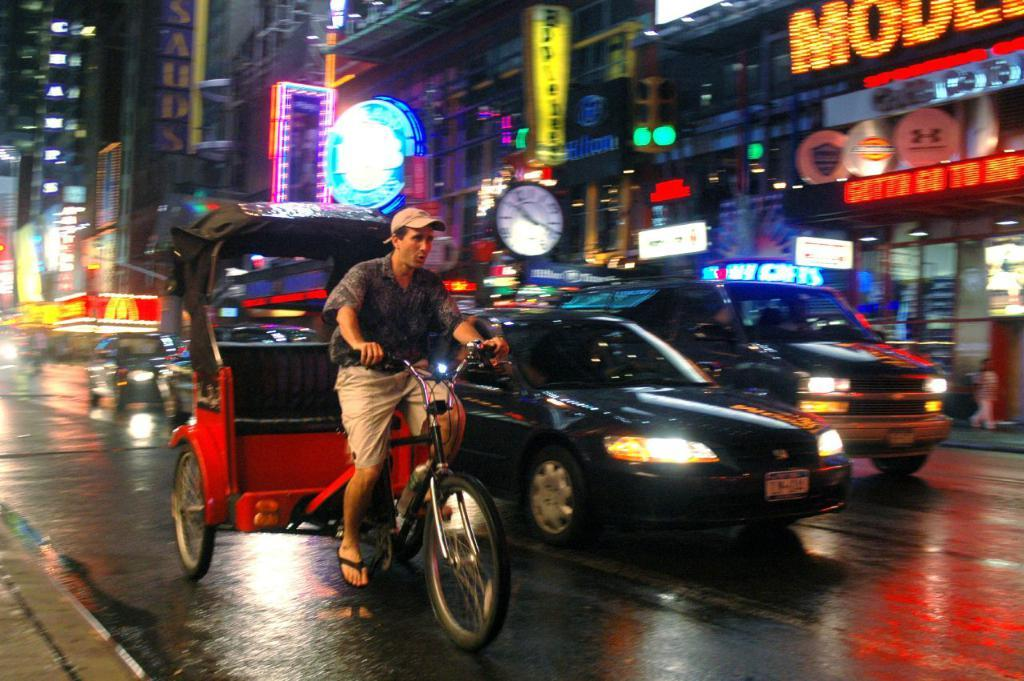<image>
Share a concise interpretation of the image provided. A pedicab next to a car with a New York tag on it. 